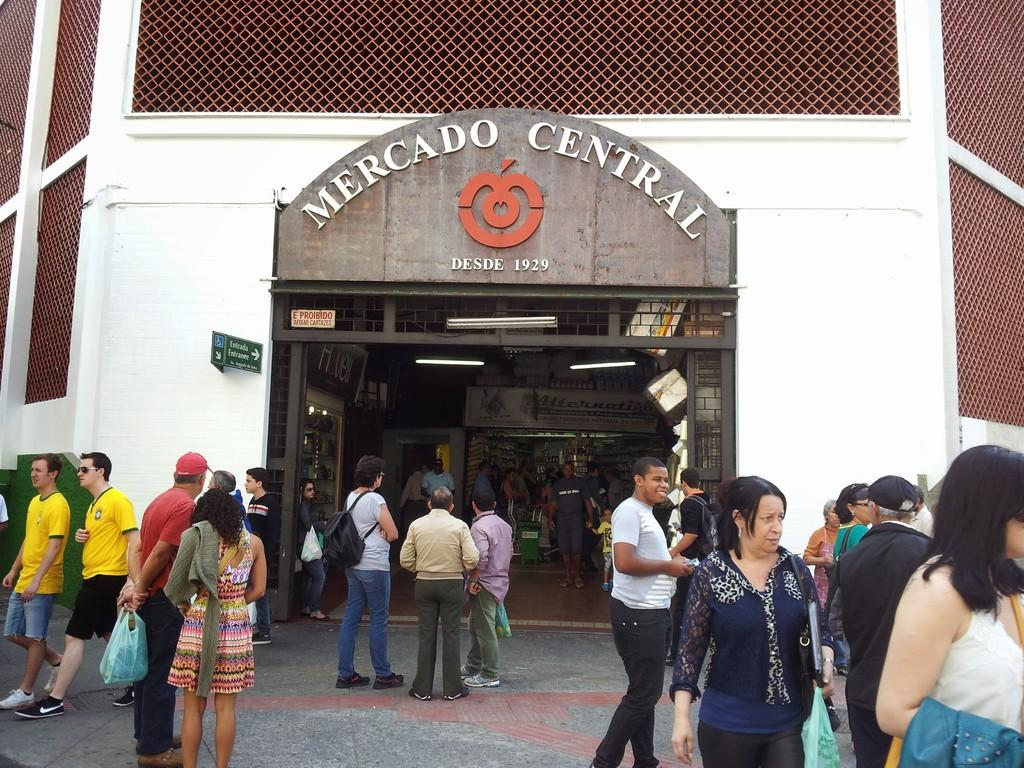Provide a one-sentence caption for the provided image. several groups of people gathered and talking in front of Mercado Central building. 